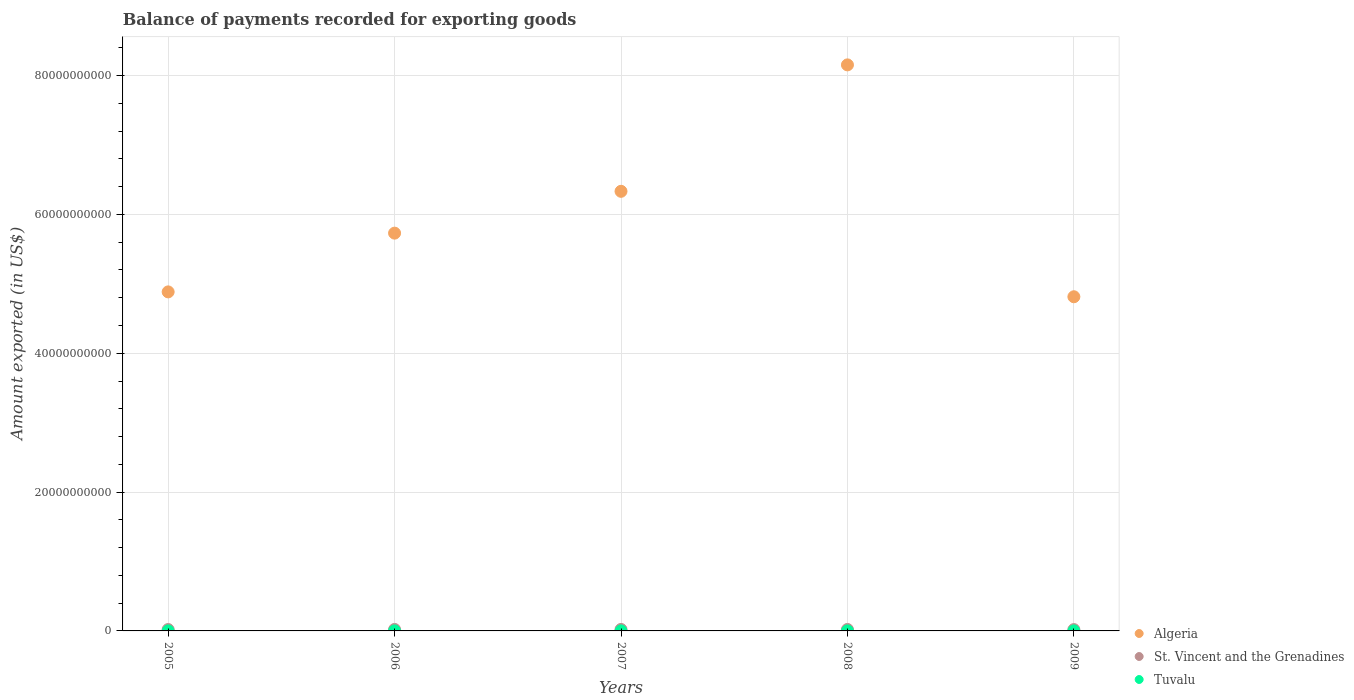How many different coloured dotlines are there?
Make the answer very short. 3. Is the number of dotlines equal to the number of legend labels?
Ensure brevity in your answer.  Yes. What is the amount exported in St. Vincent and the Grenadines in 2006?
Your answer should be very brief. 2.12e+08. Across all years, what is the maximum amount exported in St. Vincent and the Grenadines?
Give a very brief answer. 2.12e+08. Across all years, what is the minimum amount exported in St. Vincent and the Grenadines?
Make the answer very short. 1.92e+08. In which year was the amount exported in Tuvalu minimum?
Ensure brevity in your answer.  2005. What is the total amount exported in Tuvalu in the graph?
Offer a very short reply. 1.85e+07. What is the difference between the amount exported in Tuvalu in 2005 and that in 2009?
Provide a succinct answer. -2.89e+06. What is the difference between the amount exported in Tuvalu in 2006 and the amount exported in St. Vincent and the Grenadines in 2007?
Ensure brevity in your answer.  -2.09e+08. What is the average amount exported in Algeria per year?
Ensure brevity in your answer.  5.98e+1. In the year 2009, what is the difference between the amount exported in Algeria and amount exported in St. Vincent and the Grenadines?
Offer a terse response. 4.79e+1. What is the ratio of the amount exported in Algeria in 2005 to that in 2007?
Ensure brevity in your answer.  0.77. Is the amount exported in Algeria in 2006 less than that in 2009?
Your answer should be very brief. No. What is the difference between the highest and the second highest amount exported in Tuvalu?
Offer a terse response. 1.45e+06. What is the difference between the highest and the lowest amount exported in Algeria?
Offer a terse response. 3.34e+1. Is it the case that in every year, the sum of the amount exported in Algeria and amount exported in Tuvalu  is greater than the amount exported in St. Vincent and the Grenadines?
Ensure brevity in your answer.  Yes. Is the amount exported in Tuvalu strictly greater than the amount exported in Algeria over the years?
Your response must be concise. No. How many dotlines are there?
Give a very brief answer. 3. How many years are there in the graph?
Provide a succinct answer. 5. What is the difference between two consecutive major ticks on the Y-axis?
Provide a short and direct response. 2.00e+1. Are the values on the major ticks of Y-axis written in scientific E-notation?
Make the answer very short. No. Does the graph contain grids?
Keep it short and to the point. Yes. How many legend labels are there?
Make the answer very short. 3. What is the title of the graph?
Provide a short and direct response. Balance of payments recorded for exporting goods. What is the label or title of the Y-axis?
Your answer should be compact. Amount exported (in US$). What is the Amount exported (in US$) in Algeria in 2005?
Your answer should be very brief. 4.88e+1. What is the Amount exported (in US$) of St. Vincent and the Grenadines in 2005?
Give a very brief answer. 2.01e+08. What is the Amount exported (in US$) in Tuvalu in 2005?
Provide a short and direct response. 2.63e+06. What is the Amount exported (in US$) of Algeria in 2006?
Make the answer very short. 5.73e+1. What is the Amount exported (in US$) of St. Vincent and the Grenadines in 2006?
Offer a very short reply. 2.12e+08. What is the Amount exported (in US$) in Tuvalu in 2006?
Offer a terse response. 3.02e+06. What is the Amount exported (in US$) of Algeria in 2007?
Give a very brief answer. 6.33e+1. What is the Amount exported (in US$) of St. Vincent and the Grenadines in 2007?
Provide a succinct answer. 2.12e+08. What is the Amount exported (in US$) in Tuvalu in 2007?
Provide a short and direct response. 3.27e+06. What is the Amount exported (in US$) in Algeria in 2008?
Your response must be concise. 8.15e+1. What is the Amount exported (in US$) in St. Vincent and the Grenadines in 2008?
Your answer should be compact. 2.10e+08. What is the Amount exported (in US$) in Tuvalu in 2008?
Ensure brevity in your answer.  4.06e+06. What is the Amount exported (in US$) in Algeria in 2009?
Offer a terse response. 4.81e+1. What is the Amount exported (in US$) in St. Vincent and the Grenadines in 2009?
Ensure brevity in your answer.  1.92e+08. What is the Amount exported (in US$) of Tuvalu in 2009?
Keep it short and to the point. 5.51e+06. Across all years, what is the maximum Amount exported (in US$) of Algeria?
Offer a terse response. 8.15e+1. Across all years, what is the maximum Amount exported (in US$) in St. Vincent and the Grenadines?
Ensure brevity in your answer.  2.12e+08. Across all years, what is the maximum Amount exported (in US$) in Tuvalu?
Your answer should be compact. 5.51e+06. Across all years, what is the minimum Amount exported (in US$) of Algeria?
Your answer should be compact. 4.81e+1. Across all years, what is the minimum Amount exported (in US$) in St. Vincent and the Grenadines?
Provide a succinct answer. 1.92e+08. Across all years, what is the minimum Amount exported (in US$) in Tuvalu?
Keep it short and to the point. 2.63e+06. What is the total Amount exported (in US$) in Algeria in the graph?
Provide a succinct answer. 2.99e+11. What is the total Amount exported (in US$) of St. Vincent and the Grenadines in the graph?
Ensure brevity in your answer.  1.03e+09. What is the total Amount exported (in US$) of Tuvalu in the graph?
Your answer should be very brief. 1.85e+07. What is the difference between the Amount exported (in US$) of Algeria in 2005 and that in 2006?
Offer a very short reply. -8.46e+09. What is the difference between the Amount exported (in US$) in St. Vincent and the Grenadines in 2005 and that in 2006?
Your response must be concise. -1.14e+07. What is the difference between the Amount exported (in US$) in Tuvalu in 2005 and that in 2006?
Keep it short and to the point. -3.88e+05. What is the difference between the Amount exported (in US$) of Algeria in 2005 and that in 2007?
Offer a very short reply. -1.45e+1. What is the difference between the Amount exported (in US$) of St. Vincent and the Grenadines in 2005 and that in 2007?
Ensure brevity in your answer.  -1.17e+07. What is the difference between the Amount exported (in US$) of Tuvalu in 2005 and that in 2007?
Keep it short and to the point. -6.39e+05. What is the difference between the Amount exported (in US$) in Algeria in 2005 and that in 2008?
Provide a short and direct response. -3.27e+1. What is the difference between the Amount exported (in US$) of St. Vincent and the Grenadines in 2005 and that in 2008?
Your response must be concise. -9.62e+06. What is the difference between the Amount exported (in US$) of Tuvalu in 2005 and that in 2008?
Offer a very short reply. -1.43e+06. What is the difference between the Amount exported (in US$) in Algeria in 2005 and that in 2009?
Offer a terse response. 7.01e+08. What is the difference between the Amount exported (in US$) in St. Vincent and the Grenadines in 2005 and that in 2009?
Your response must be concise. 8.24e+06. What is the difference between the Amount exported (in US$) in Tuvalu in 2005 and that in 2009?
Your answer should be very brief. -2.89e+06. What is the difference between the Amount exported (in US$) in Algeria in 2006 and that in 2007?
Offer a very short reply. -6.03e+09. What is the difference between the Amount exported (in US$) in St. Vincent and the Grenadines in 2006 and that in 2007?
Your answer should be compact. -2.26e+05. What is the difference between the Amount exported (in US$) of Tuvalu in 2006 and that in 2007?
Your answer should be very brief. -2.51e+05. What is the difference between the Amount exported (in US$) in Algeria in 2006 and that in 2008?
Give a very brief answer. -2.42e+1. What is the difference between the Amount exported (in US$) in St. Vincent and the Grenadines in 2006 and that in 2008?
Give a very brief answer. 1.83e+06. What is the difference between the Amount exported (in US$) in Tuvalu in 2006 and that in 2008?
Offer a terse response. -1.05e+06. What is the difference between the Amount exported (in US$) of Algeria in 2006 and that in 2009?
Make the answer very short. 9.16e+09. What is the difference between the Amount exported (in US$) of St. Vincent and the Grenadines in 2006 and that in 2009?
Give a very brief answer. 1.97e+07. What is the difference between the Amount exported (in US$) of Tuvalu in 2006 and that in 2009?
Your response must be concise. -2.50e+06. What is the difference between the Amount exported (in US$) of Algeria in 2007 and that in 2008?
Your response must be concise. -1.82e+1. What is the difference between the Amount exported (in US$) of St. Vincent and the Grenadines in 2007 and that in 2008?
Ensure brevity in your answer.  2.05e+06. What is the difference between the Amount exported (in US$) of Tuvalu in 2007 and that in 2008?
Keep it short and to the point. -7.94e+05. What is the difference between the Amount exported (in US$) of Algeria in 2007 and that in 2009?
Give a very brief answer. 1.52e+1. What is the difference between the Amount exported (in US$) of St. Vincent and the Grenadines in 2007 and that in 2009?
Provide a succinct answer. 1.99e+07. What is the difference between the Amount exported (in US$) in Tuvalu in 2007 and that in 2009?
Your response must be concise. -2.25e+06. What is the difference between the Amount exported (in US$) in Algeria in 2008 and that in 2009?
Keep it short and to the point. 3.34e+1. What is the difference between the Amount exported (in US$) of St. Vincent and the Grenadines in 2008 and that in 2009?
Give a very brief answer. 1.79e+07. What is the difference between the Amount exported (in US$) in Tuvalu in 2008 and that in 2009?
Keep it short and to the point. -1.45e+06. What is the difference between the Amount exported (in US$) in Algeria in 2005 and the Amount exported (in US$) in St. Vincent and the Grenadines in 2006?
Provide a succinct answer. 4.86e+1. What is the difference between the Amount exported (in US$) of Algeria in 2005 and the Amount exported (in US$) of Tuvalu in 2006?
Provide a succinct answer. 4.88e+1. What is the difference between the Amount exported (in US$) of St. Vincent and the Grenadines in 2005 and the Amount exported (in US$) of Tuvalu in 2006?
Offer a terse response. 1.98e+08. What is the difference between the Amount exported (in US$) of Algeria in 2005 and the Amount exported (in US$) of St. Vincent and the Grenadines in 2007?
Offer a terse response. 4.86e+1. What is the difference between the Amount exported (in US$) of Algeria in 2005 and the Amount exported (in US$) of Tuvalu in 2007?
Ensure brevity in your answer.  4.88e+1. What is the difference between the Amount exported (in US$) in St. Vincent and the Grenadines in 2005 and the Amount exported (in US$) in Tuvalu in 2007?
Make the answer very short. 1.97e+08. What is the difference between the Amount exported (in US$) in Algeria in 2005 and the Amount exported (in US$) in St. Vincent and the Grenadines in 2008?
Keep it short and to the point. 4.86e+1. What is the difference between the Amount exported (in US$) in Algeria in 2005 and the Amount exported (in US$) in Tuvalu in 2008?
Give a very brief answer. 4.88e+1. What is the difference between the Amount exported (in US$) in St. Vincent and the Grenadines in 2005 and the Amount exported (in US$) in Tuvalu in 2008?
Give a very brief answer. 1.96e+08. What is the difference between the Amount exported (in US$) of Algeria in 2005 and the Amount exported (in US$) of St. Vincent and the Grenadines in 2009?
Make the answer very short. 4.86e+1. What is the difference between the Amount exported (in US$) of Algeria in 2005 and the Amount exported (in US$) of Tuvalu in 2009?
Offer a very short reply. 4.88e+1. What is the difference between the Amount exported (in US$) in St. Vincent and the Grenadines in 2005 and the Amount exported (in US$) in Tuvalu in 2009?
Ensure brevity in your answer.  1.95e+08. What is the difference between the Amount exported (in US$) in Algeria in 2006 and the Amount exported (in US$) in St. Vincent and the Grenadines in 2007?
Your answer should be very brief. 5.71e+1. What is the difference between the Amount exported (in US$) in Algeria in 2006 and the Amount exported (in US$) in Tuvalu in 2007?
Make the answer very short. 5.73e+1. What is the difference between the Amount exported (in US$) of St. Vincent and the Grenadines in 2006 and the Amount exported (in US$) of Tuvalu in 2007?
Give a very brief answer. 2.09e+08. What is the difference between the Amount exported (in US$) of Algeria in 2006 and the Amount exported (in US$) of St. Vincent and the Grenadines in 2008?
Provide a short and direct response. 5.71e+1. What is the difference between the Amount exported (in US$) of Algeria in 2006 and the Amount exported (in US$) of Tuvalu in 2008?
Provide a succinct answer. 5.73e+1. What is the difference between the Amount exported (in US$) in St. Vincent and the Grenadines in 2006 and the Amount exported (in US$) in Tuvalu in 2008?
Ensure brevity in your answer.  2.08e+08. What is the difference between the Amount exported (in US$) in Algeria in 2006 and the Amount exported (in US$) in St. Vincent and the Grenadines in 2009?
Your answer should be compact. 5.71e+1. What is the difference between the Amount exported (in US$) of Algeria in 2006 and the Amount exported (in US$) of Tuvalu in 2009?
Your answer should be very brief. 5.73e+1. What is the difference between the Amount exported (in US$) of St. Vincent and the Grenadines in 2006 and the Amount exported (in US$) of Tuvalu in 2009?
Your answer should be very brief. 2.06e+08. What is the difference between the Amount exported (in US$) in Algeria in 2007 and the Amount exported (in US$) in St. Vincent and the Grenadines in 2008?
Provide a succinct answer. 6.31e+1. What is the difference between the Amount exported (in US$) in Algeria in 2007 and the Amount exported (in US$) in Tuvalu in 2008?
Offer a terse response. 6.33e+1. What is the difference between the Amount exported (in US$) in St. Vincent and the Grenadines in 2007 and the Amount exported (in US$) in Tuvalu in 2008?
Give a very brief answer. 2.08e+08. What is the difference between the Amount exported (in US$) in Algeria in 2007 and the Amount exported (in US$) in St. Vincent and the Grenadines in 2009?
Provide a succinct answer. 6.31e+1. What is the difference between the Amount exported (in US$) of Algeria in 2007 and the Amount exported (in US$) of Tuvalu in 2009?
Offer a terse response. 6.33e+1. What is the difference between the Amount exported (in US$) in St. Vincent and the Grenadines in 2007 and the Amount exported (in US$) in Tuvalu in 2009?
Your answer should be compact. 2.07e+08. What is the difference between the Amount exported (in US$) in Algeria in 2008 and the Amount exported (in US$) in St. Vincent and the Grenadines in 2009?
Your response must be concise. 8.14e+1. What is the difference between the Amount exported (in US$) in Algeria in 2008 and the Amount exported (in US$) in Tuvalu in 2009?
Give a very brief answer. 8.15e+1. What is the difference between the Amount exported (in US$) in St. Vincent and the Grenadines in 2008 and the Amount exported (in US$) in Tuvalu in 2009?
Offer a very short reply. 2.05e+08. What is the average Amount exported (in US$) in Algeria per year?
Ensure brevity in your answer.  5.98e+1. What is the average Amount exported (in US$) in St. Vincent and the Grenadines per year?
Offer a very short reply. 2.05e+08. What is the average Amount exported (in US$) in Tuvalu per year?
Keep it short and to the point. 3.70e+06. In the year 2005, what is the difference between the Amount exported (in US$) of Algeria and Amount exported (in US$) of St. Vincent and the Grenadines?
Your answer should be very brief. 4.86e+1. In the year 2005, what is the difference between the Amount exported (in US$) of Algeria and Amount exported (in US$) of Tuvalu?
Provide a short and direct response. 4.88e+1. In the year 2005, what is the difference between the Amount exported (in US$) in St. Vincent and the Grenadines and Amount exported (in US$) in Tuvalu?
Ensure brevity in your answer.  1.98e+08. In the year 2006, what is the difference between the Amount exported (in US$) of Algeria and Amount exported (in US$) of St. Vincent and the Grenadines?
Keep it short and to the point. 5.71e+1. In the year 2006, what is the difference between the Amount exported (in US$) in Algeria and Amount exported (in US$) in Tuvalu?
Provide a short and direct response. 5.73e+1. In the year 2006, what is the difference between the Amount exported (in US$) in St. Vincent and the Grenadines and Amount exported (in US$) in Tuvalu?
Your answer should be compact. 2.09e+08. In the year 2007, what is the difference between the Amount exported (in US$) of Algeria and Amount exported (in US$) of St. Vincent and the Grenadines?
Keep it short and to the point. 6.31e+1. In the year 2007, what is the difference between the Amount exported (in US$) of Algeria and Amount exported (in US$) of Tuvalu?
Your answer should be compact. 6.33e+1. In the year 2007, what is the difference between the Amount exported (in US$) of St. Vincent and the Grenadines and Amount exported (in US$) of Tuvalu?
Make the answer very short. 2.09e+08. In the year 2008, what is the difference between the Amount exported (in US$) of Algeria and Amount exported (in US$) of St. Vincent and the Grenadines?
Keep it short and to the point. 8.13e+1. In the year 2008, what is the difference between the Amount exported (in US$) in Algeria and Amount exported (in US$) in Tuvalu?
Provide a succinct answer. 8.15e+1. In the year 2008, what is the difference between the Amount exported (in US$) in St. Vincent and the Grenadines and Amount exported (in US$) in Tuvalu?
Your answer should be very brief. 2.06e+08. In the year 2009, what is the difference between the Amount exported (in US$) of Algeria and Amount exported (in US$) of St. Vincent and the Grenadines?
Ensure brevity in your answer.  4.79e+1. In the year 2009, what is the difference between the Amount exported (in US$) in Algeria and Amount exported (in US$) in Tuvalu?
Offer a very short reply. 4.81e+1. In the year 2009, what is the difference between the Amount exported (in US$) in St. Vincent and the Grenadines and Amount exported (in US$) in Tuvalu?
Give a very brief answer. 1.87e+08. What is the ratio of the Amount exported (in US$) of Algeria in 2005 to that in 2006?
Your answer should be very brief. 0.85. What is the ratio of the Amount exported (in US$) of St. Vincent and the Grenadines in 2005 to that in 2006?
Your response must be concise. 0.95. What is the ratio of the Amount exported (in US$) in Tuvalu in 2005 to that in 2006?
Give a very brief answer. 0.87. What is the ratio of the Amount exported (in US$) of Algeria in 2005 to that in 2007?
Your response must be concise. 0.77. What is the ratio of the Amount exported (in US$) of St. Vincent and the Grenadines in 2005 to that in 2007?
Make the answer very short. 0.94. What is the ratio of the Amount exported (in US$) in Tuvalu in 2005 to that in 2007?
Your answer should be very brief. 0.8. What is the ratio of the Amount exported (in US$) in Algeria in 2005 to that in 2008?
Provide a short and direct response. 0.6. What is the ratio of the Amount exported (in US$) in St. Vincent and the Grenadines in 2005 to that in 2008?
Give a very brief answer. 0.95. What is the ratio of the Amount exported (in US$) of Tuvalu in 2005 to that in 2008?
Make the answer very short. 0.65. What is the ratio of the Amount exported (in US$) of Algeria in 2005 to that in 2009?
Offer a very short reply. 1.01. What is the ratio of the Amount exported (in US$) in St. Vincent and the Grenadines in 2005 to that in 2009?
Keep it short and to the point. 1.04. What is the ratio of the Amount exported (in US$) in Tuvalu in 2005 to that in 2009?
Your answer should be very brief. 0.48. What is the ratio of the Amount exported (in US$) of Algeria in 2006 to that in 2007?
Ensure brevity in your answer.  0.9. What is the ratio of the Amount exported (in US$) in St. Vincent and the Grenadines in 2006 to that in 2007?
Ensure brevity in your answer.  1. What is the ratio of the Amount exported (in US$) in Tuvalu in 2006 to that in 2007?
Make the answer very short. 0.92. What is the ratio of the Amount exported (in US$) in Algeria in 2006 to that in 2008?
Provide a succinct answer. 0.7. What is the ratio of the Amount exported (in US$) in St. Vincent and the Grenadines in 2006 to that in 2008?
Provide a short and direct response. 1.01. What is the ratio of the Amount exported (in US$) in Tuvalu in 2006 to that in 2008?
Provide a succinct answer. 0.74. What is the ratio of the Amount exported (in US$) of Algeria in 2006 to that in 2009?
Your response must be concise. 1.19. What is the ratio of the Amount exported (in US$) in St. Vincent and the Grenadines in 2006 to that in 2009?
Provide a succinct answer. 1.1. What is the ratio of the Amount exported (in US$) in Tuvalu in 2006 to that in 2009?
Offer a very short reply. 0.55. What is the ratio of the Amount exported (in US$) of Algeria in 2007 to that in 2008?
Provide a succinct answer. 0.78. What is the ratio of the Amount exported (in US$) of St. Vincent and the Grenadines in 2007 to that in 2008?
Offer a very short reply. 1.01. What is the ratio of the Amount exported (in US$) of Tuvalu in 2007 to that in 2008?
Your answer should be compact. 0.8. What is the ratio of the Amount exported (in US$) in Algeria in 2007 to that in 2009?
Provide a succinct answer. 1.32. What is the ratio of the Amount exported (in US$) in St. Vincent and the Grenadines in 2007 to that in 2009?
Offer a terse response. 1.1. What is the ratio of the Amount exported (in US$) in Tuvalu in 2007 to that in 2009?
Your answer should be compact. 0.59. What is the ratio of the Amount exported (in US$) in Algeria in 2008 to that in 2009?
Offer a very short reply. 1.69. What is the ratio of the Amount exported (in US$) in St. Vincent and the Grenadines in 2008 to that in 2009?
Offer a very short reply. 1.09. What is the ratio of the Amount exported (in US$) in Tuvalu in 2008 to that in 2009?
Provide a succinct answer. 0.74. What is the difference between the highest and the second highest Amount exported (in US$) in Algeria?
Keep it short and to the point. 1.82e+1. What is the difference between the highest and the second highest Amount exported (in US$) in St. Vincent and the Grenadines?
Ensure brevity in your answer.  2.26e+05. What is the difference between the highest and the second highest Amount exported (in US$) in Tuvalu?
Your response must be concise. 1.45e+06. What is the difference between the highest and the lowest Amount exported (in US$) in Algeria?
Offer a terse response. 3.34e+1. What is the difference between the highest and the lowest Amount exported (in US$) of St. Vincent and the Grenadines?
Make the answer very short. 1.99e+07. What is the difference between the highest and the lowest Amount exported (in US$) in Tuvalu?
Provide a succinct answer. 2.89e+06. 